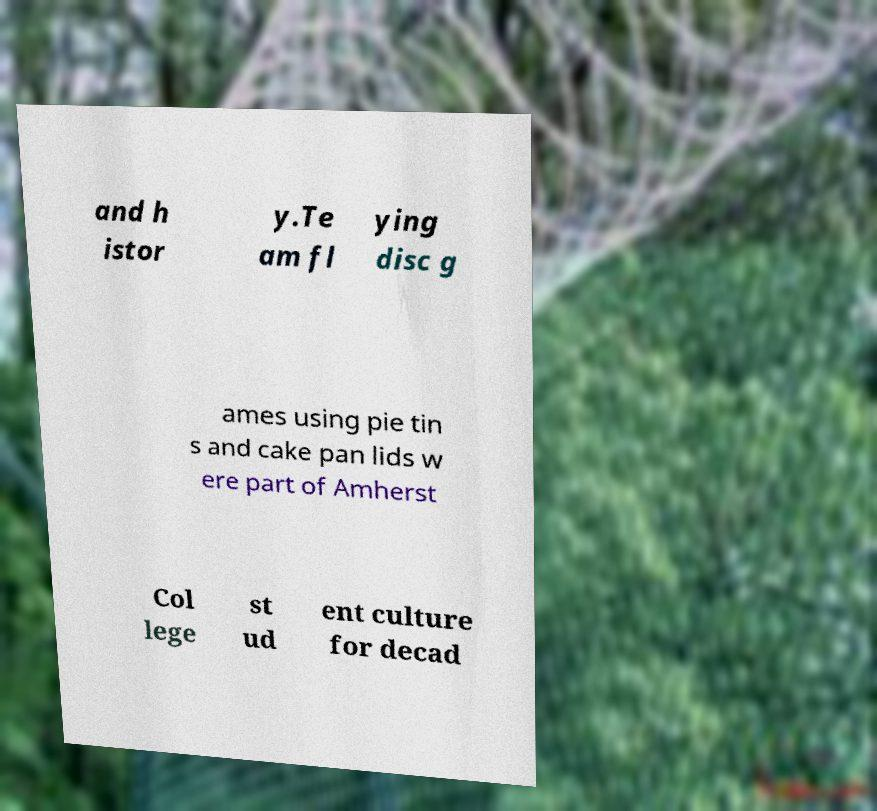For documentation purposes, I need the text within this image transcribed. Could you provide that? and h istor y.Te am fl ying disc g ames using pie tin s and cake pan lids w ere part of Amherst Col lege st ud ent culture for decad 